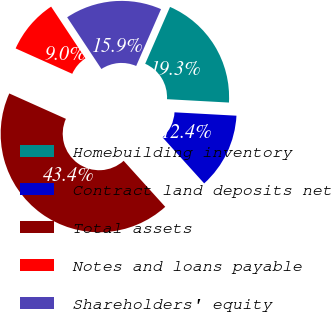Convert chart to OTSL. <chart><loc_0><loc_0><loc_500><loc_500><pie_chart><fcel>Homebuilding inventory<fcel>Contract land deposits net<fcel>Total assets<fcel>Notes and loans payable<fcel>Shareholders' equity<nl><fcel>19.31%<fcel>12.43%<fcel>43.41%<fcel>8.98%<fcel>15.87%<nl></chart> 